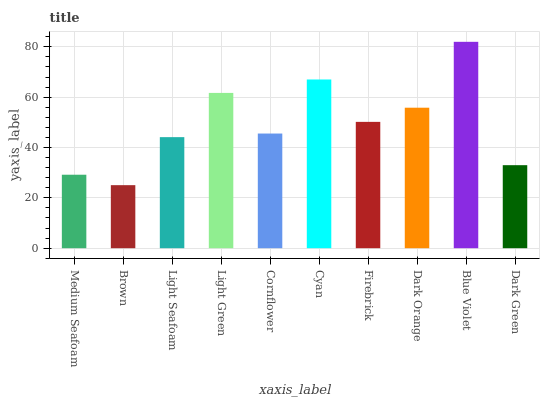Is Brown the minimum?
Answer yes or no. Yes. Is Blue Violet the maximum?
Answer yes or no. Yes. Is Light Seafoam the minimum?
Answer yes or no. No. Is Light Seafoam the maximum?
Answer yes or no. No. Is Light Seafoam greater than Brown?
Answer yes or no. Yes. Is Brown less than Light Seafoam?
Answer yes or no. Yes. Is Brown greater than Light Seafoam?
Answer yes or no. No. Is Light Seafoam less than Brown?
Answer yes or no. No. Is Firebrick the high median?
Answer yes or no. Yes. Is Cornflower the low median?
Answer yes or no. Yes. Is Light Seafoam the high median?
Answer yes or no. No. Is Dark Orange the low median?
Answer yes or no. No. 